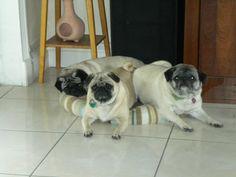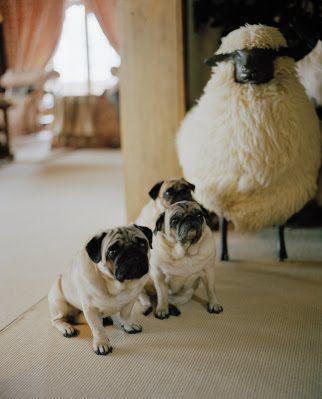The first image is the image on the left, the second image is the image on the right. Evaluate the accuracy of this statement regarding the images: "In at least one image there are three pugs sharing one dog bed.". Is it true? Answer yes or no. Yes. The first image is the image on the left, the second image is the image on the right. Evaluate the accuracy of this statement regarding the images: "All dogs shown are buff-beige pugs with darker muzzles, and one image contains three pugs sitting upright, while the other image contains at least two pugs on a type of bed.". Is it true? Answer yes or no. Yes. 